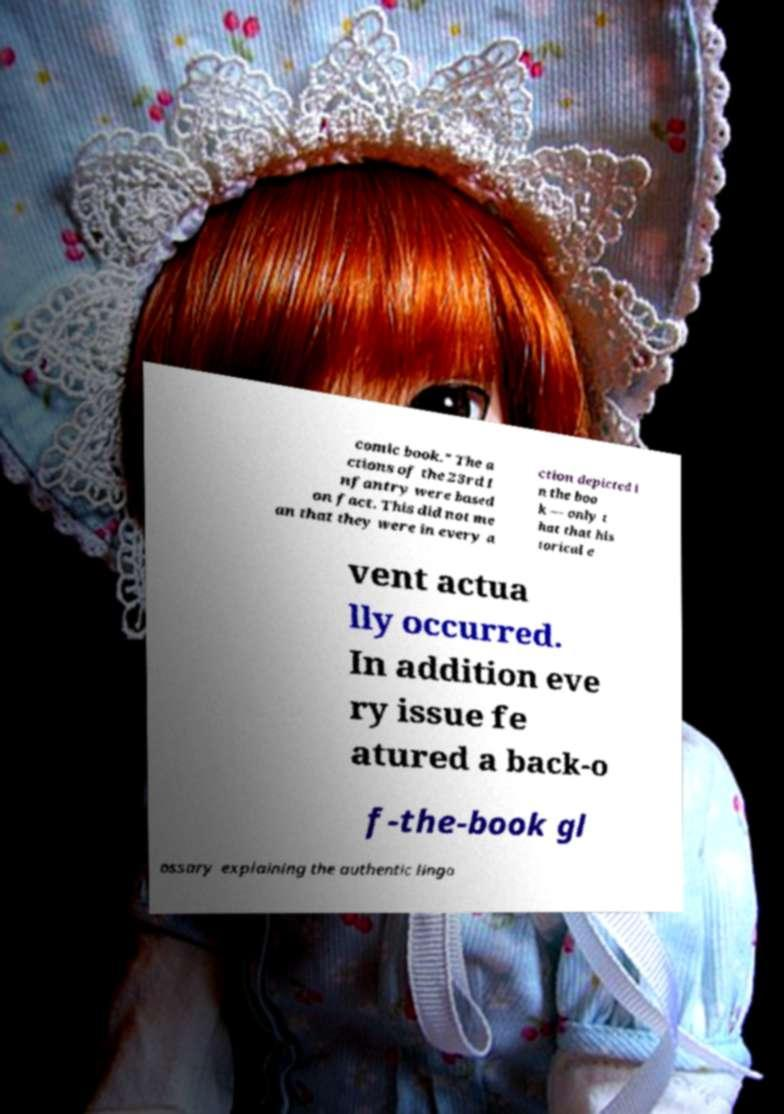Please read and relay the text visible in this image. What does it say? comic book." The a ctions of the 23rd I nfantry were based on fact. This did not me an that they were in every a ction depicted i n the boo k — only t hat that his torical e vent actua lly occurred. In addition eve ry issue fe atured a back-o f-the-book gl ossary explaining the authentic lingo 